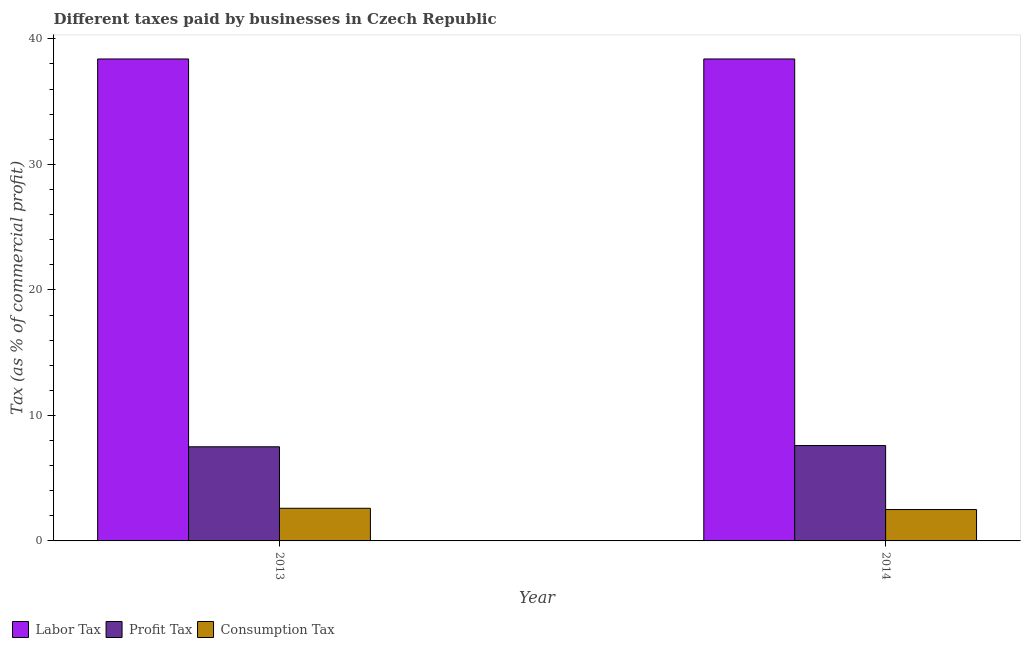How many different coloured bars are there?
Your answer should be very brief. 3. How many groups of bars are there?
Give a very brief answer. 2. Are the number of bars per tick equal to the number of legend labels?
Your answer should be compact. Yes. Are the number of bars on each tick of the X-axis equal?
Provide a short and direct response. Yes. How many bars are there on the 1st tick from the right?
Your answer should be very brief. 3. What is the label of the 1st group of bars from the left?
Ensure brevity in your answer.  2013. In how many cases, is the number of bars for a given year not equal to the number of legend labels?
Offer a very short reply. 0. Across all years, what is the maximum percentage of labor tax?
Ensure brevity in your answer.  38.4. Across all years, what is the minimum percentage of labor tax?
Keep it short and to the point. 38.4. What is the total percentage of consumption tax in the graph?
Provide a succinct answer. 5.1. What is the difference between the percentage of consumption tax in 2013 and the percentage of profit tax in 2014?
Ensure brevity in your answer.  0.1. What is the average percentage of profit tax per year?
Ensure brevity in your answer.  7.55. In the year 2014, what is the difference between the percentage of profit tax and percentage of labor tax?
Your answer should be very brief. 0. Is the percentage of labor tax in 2013 less than that in 2014?
Give a very brief answer. No. In how many years, is the percentage of consumption tax greater than the average percentage of consumption tax taken over all years?
Keep it short and to the point. 1. What does the 3rd bar from the left in 2014 represents?
Your answer should be compact. Consumption Tax. What does the 3rd bar from the right in 2013 represents?
Offer a terse response. Labor Tax. How many bars are there?
Give a very brief answer. 6. Are all the bars in the graph horizontal?
Provide a succinct answer. No. Are the values on the major ticks of Y-axis written in scientific E-notation?
Offer a terse response. No. Does the graph contain any zero values?
Give a very brief answer. No. Does the graph contain grids?
Provide a succinct answer. No. How many legend labels are there?
Provide a short and direct response. 3. How are the legend labels stacked?
Keep it short and to the point. Horizontal. What is the title of the graph?
Your answer should be very brief. Different taxes paid by businesses in Czech Republic. What is the label or title of the X-axis?
Keep it short and to the point. Year. What is the label or title of the Y-axis?
Keep it short and to the point. Tax (as % of commercial profit). What is the Tax (as % of commercial profit) in Labor Tax in 2013?
Make the answer very short. 38.4. What is the Tax (as % of commercial profit) of Labor Tax in 2014?
Your answer should be very brief. 38.4. What is the Tax (as % of commercial profit) in Profit Tax in 2014?
Your answer should be very brief. 7.6. Across all years, what is the maximum Tax (as % of commercial profit) of Labor Tax?
Offer a terse response. 38.4. Across all years, what is the maximum Tax (as % of commercial profit) in Profit Tax?
Offer a terse response. 7.6. Across all years, what is the minimum Tax (as % of commercial profit) in Labor Tax?
Your answer should be compact. 38.4. Across all years, what is the minimum Tax (as % of commercial profit) of Profit Tax?
Your response must be concise. 7.5. Across all years, what is the minimum Tax (as % of commercial profit) in Consumption Tax?
Offer a terse response. 2.5. What is the total Tax (as % of commercial profit) in Labor Tax in the graph?
Provide a short and direct response. 76.8. What is the total Tax (as % of commercial profit) in Consumption Tax in the graph?
Keep it short and to the point. 5.1. What is the difference between the Tax (as % of commercial profit) in Profit Tax in 2013 and that in 2014?
Your answer should be very brief. -0.1. What is the difference between the Tax (as % of commercial profit) in Consumption Tax in 2013 and that in 2014?
Make the answer very short. 0.1. What is the difference between the Tax (as % of commercial profit) of Labor Tax in 2013 and the Tax (as % of commercial profit) of Profit Tax in 2014?
Offer a terse response. 30.8. What is the difference between the Tax (as % of commercial profit) in Labor Tax in 2013 and the Tax (as % of commercial profit) in Consumption Tax in 2014?
Your answer should be compact. 35.9. What is the difference between the Tax (as % of commercial profit) of Profit Tax in 2013 and the Tax (as % of commercial profit) of Consumption Tax in 2014?
Offer a terse response. 5. What is the average Tax (as % of commercial profit) of Labor Tax per year?
Give a very brief answer. 38.4. What is the average Tax (as % of commercial profit) in Profit Tax per year?
Your answer should be very brief. 7.55. What is the average Tax (as % of commercial profit) in Consumption Tax per year?
Keep it short and to the point. 2.55. In the year 2013, what is the difference between the Tax (as % of commercial profit) of Labor Tax and Tax (as % of commercial profit) of Profit Tax?
Your response must be concise. 30.9. In the year 2013, what is the difference between the Tax (as % of commercial profit) in Labor Tax and Tax (as % of commercial profit) in Consumption Tax?
Offer a very short reply. 35.8. In the year 2014, what is the difference between the Tax (as % of commercial profit) in Labor Tax and Tax (as % of commercial profit) in Profit Tax?
Your answer should be compact. 30.8. In the year 2014, what is the difference between the Tax (as % of commercial profit) of Labor Tax and Tax (as % of commercial profit) of Consumption Tax?
Your answer should be compact. 35.9. In the year 2014, what is the difference between the Tax (as % of commercial profit) in Profit Tax and Tax (as % of commercial profit) in Consumption Tax?
Offer a terse response. 5.1. What is the ratio of the Tax (as % of commercial profit) of Labor Tax in 2013 to that in 2014?
Provide a succinct answer. 1. What is the ratio of the Tax (as % of commercial profit) in Profit Tax in 2013 to that in 2014?
Offer a terse response. 0.99. What is the ratio of the Tax (as % of commercial profit) in Consumption Tax in 2013 to that in 2014?
Your response must be concise. 1.04. What is the difference between the highest and the second highest Tax (as % of commercial profit) in Consumption Tax?
Your answer should be compact. 0.1. What is the difference between the highest and the lowest Tax (as % of commercial profit) in Labor Tax?
Provide a succinct answer. 0. 